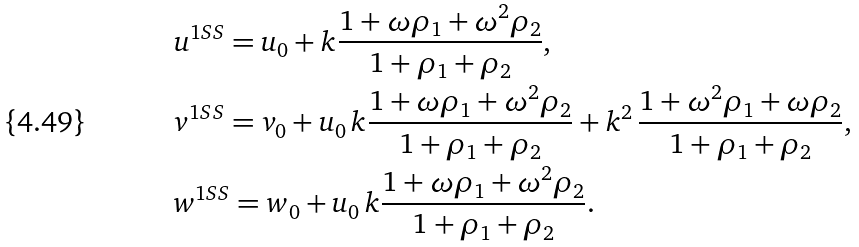Convert formula to latex. <formula><loc_0><loc_0><loc_500><loc_500>& u ^ { 1 S S } = u _ { 0 } + k \frac { 1 + \omega \rho _ { 1 } + \omega ^ { 2 } \rho _ { 2 } } { 1 + \rho _ { 1 } + \rho _ { 2 } } , \\ & v ^ { 1 S S } = v _ { 0 } + u _ { 0 } \, k \frac { 1 + \omega \rho _ { 1 } + \omega ^ { 2 } \rho _ { 2 } } { 1 + \rho _ { 1 } + \rho _ { 2 } } + k ^ { 2 } \, \frac { 1 + \omega ^ { 2 } \rho _ { 1 } + \omega \rho _ { 2 } } { 1 + \rho _ { 1 } + \rho _ { 2 } } , \\ & w ^ { 1 S S } = w _ { 0 } + u _ { 0 } \, k \frac { 1 + \omega \rho _ { 1 } + \omega ^ { 2 } \rho _ { 2 } } { 1 + \rho _ { 1 } + \rho _ { 2 } } .</formula> 